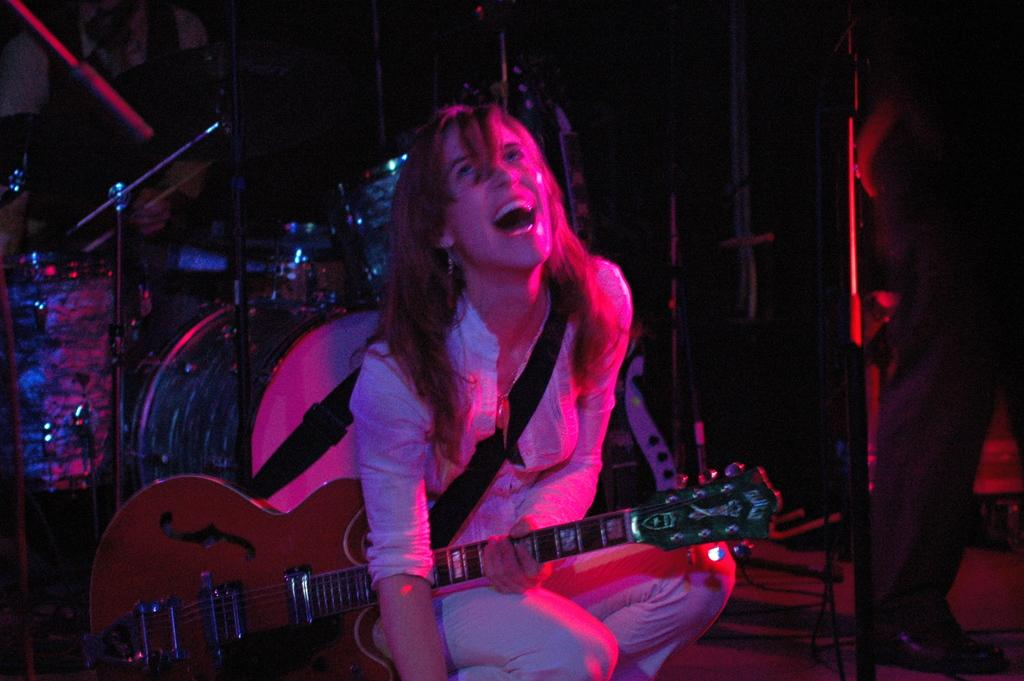Who is the main subject in the image? There is a woman in the image. What is the woman holding in the image? The woman is holding a guitar. What is the woman's expression in the image? The woman is laughing. What else can be seen in the background of the image? There are musical instruments in the background of the image. Can you tell me how many flights the woman has taken in the image? There is no information about flights in the image; it only shows a woman holding a guitar and laughing. 